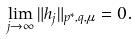Convert formula to latex. <formula><loc_0><loc_0><loc_500><loc_500>\lim _ { j \to \infty } \| h _ { j } \| _ { p ^ { * } , q , \mu } = 0 .</formula> 